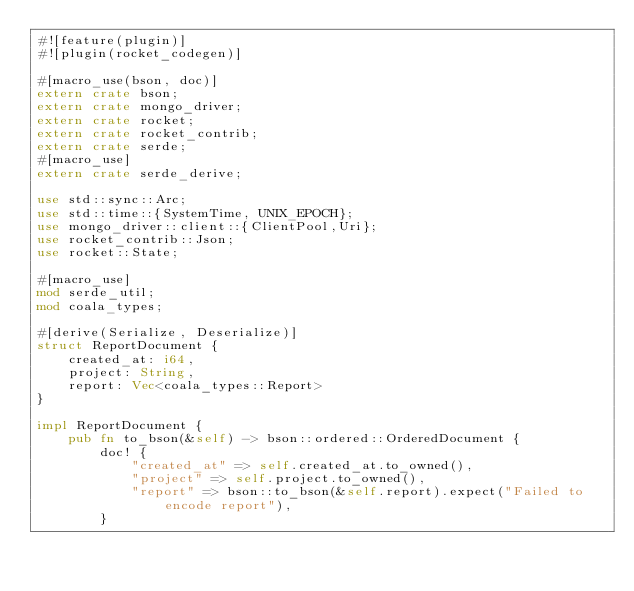Convert code to text. <code><loc_0><loc_0><loc_500><loc_500><_Rust_>#![feature(plugin)]
#![plugin(rocket_codegen)]

#[macro_use(bson, doc)]
extern crate bson;
extern crate mongo_driver;
extern crate rocket;
extern crate rocket_contrib;
extern crate serde;
#[macro_use]
extern crate serde_derive;

use std::sync::Arc;
use std::time::{SystemTime, UNIX_EPOCH};
use mongo_driver::client::{ClientPool,Uri};
use rocket_contrib::Json;
use rocket::State;

#[macro_use]
mod serde_util;
mod coala_types;

#[derive(Serialize, Deserialize)]
struct ReportDocument {
    created_at: i64,
    project: String,
    report: Vec<coala_types::Report>
}

impl ReportDocument {
    pub fn to_bson(&self) -> bson::ordered::OrderedDocument {
        doc! {
            "created_at" => self.created_at.to_owned(),
            "project" => self.project.to_owned(),
            "report" => bson::to_bson(&self.report).expect("Failed to encode report"),
        }</code> 